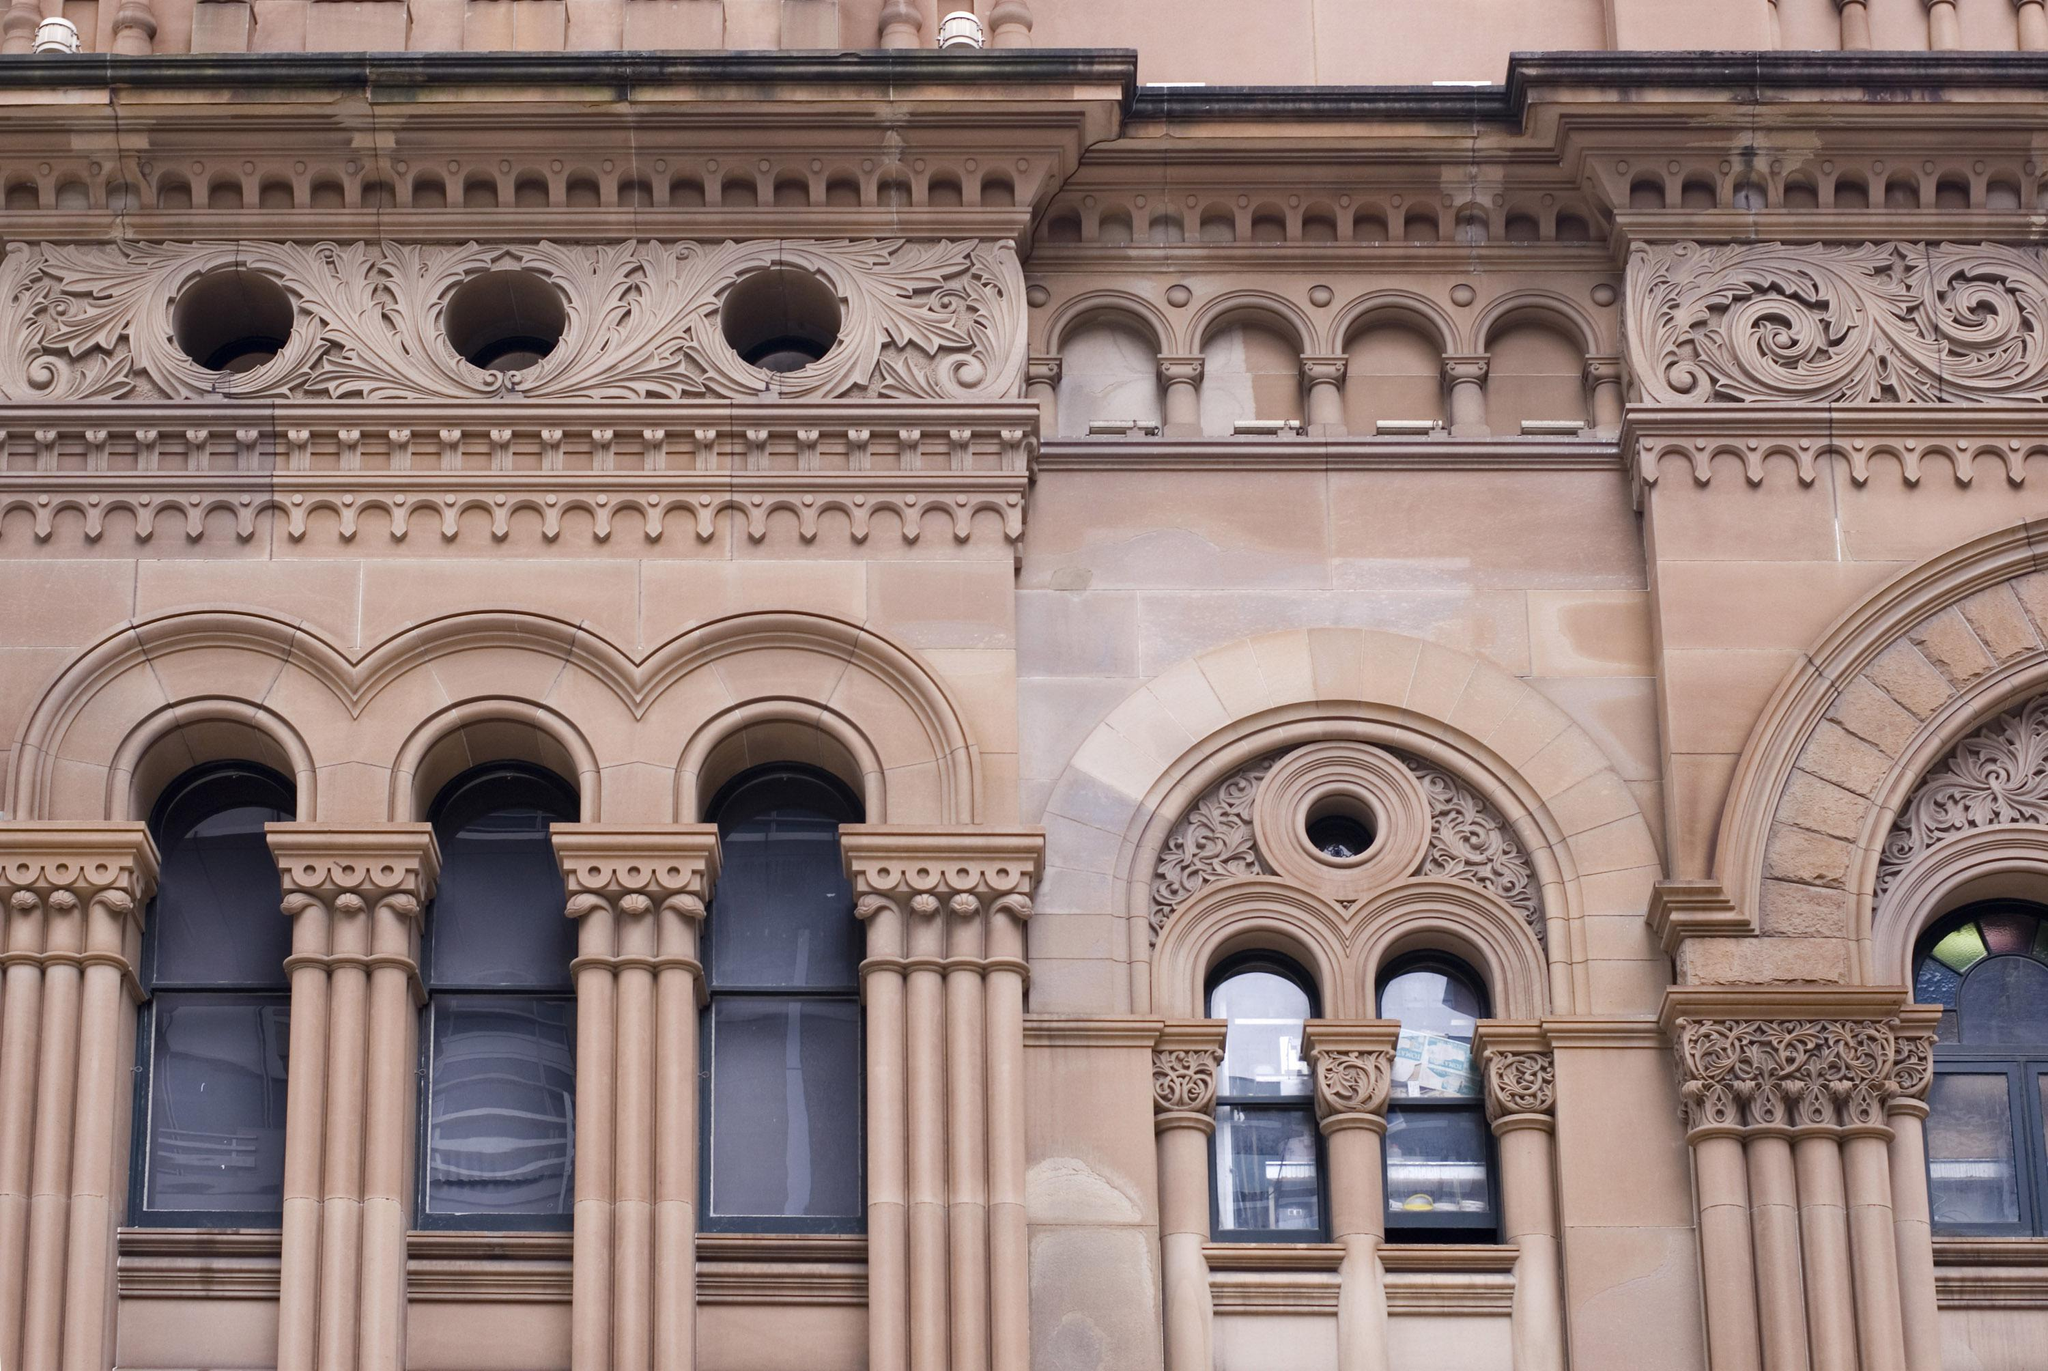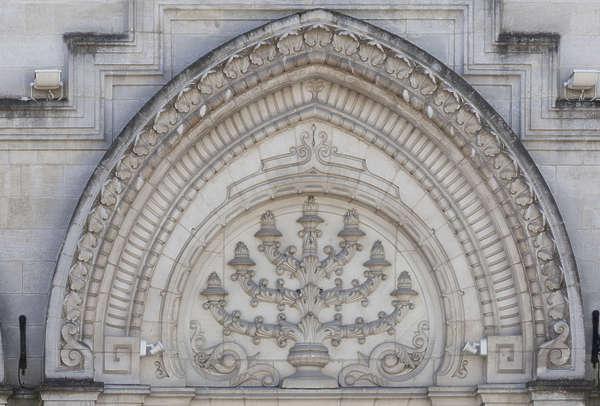The first image is the image on the left, the second image is the image on the right. For the images shown, is this caption "There is no grass or other vegetation in any of the images." true? Answer yes or no. Yes. The first image is the image on the left, the second image is the image on the right. Assess this claim about the two images: "The right image has no more than 4 arches.". Correct or not? Answer yes or no. Yes. 